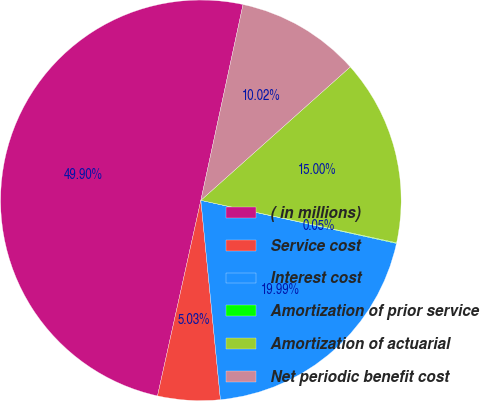<chart> <loc_0><loc_0><loc_500><loc_500><pie_chart><fcel>( in millions)<fcel>Service cost<fcel>Interest cost<fcel>Amortization of prior service<fcel>Amortization of actuarial<fcel>Net periodic benefit cost<nl><fcel>49.9%<fcel>5.03%<fcel>19.99%<fcel>0.05%<fcel>15.0%<fcel>10.02%<nl></chart> 